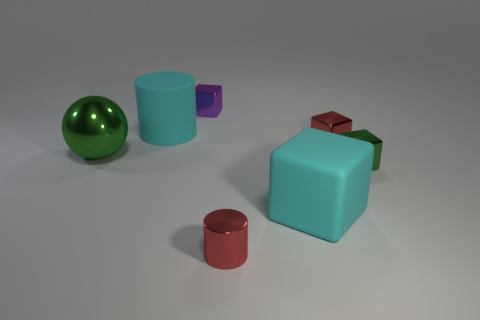How does the lighting in the image affect the appearance of the objects? The lighting in the image is soft and diffused, coming from above. It creates gentle shadows underneath the objects, enhancing their three-dimensional form without causing any harsh reflections or glare. 